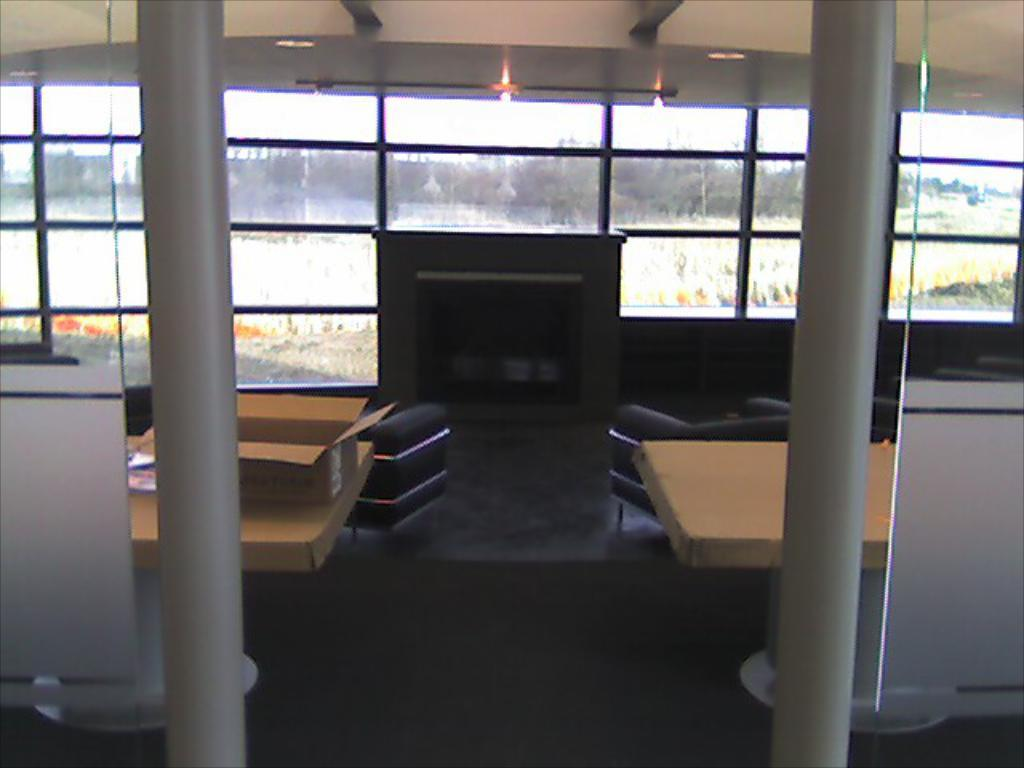What is the main piece of furniture in the image? There is a table in the image. What electronic device is on the table? There is a computer system on the table. What other objects are on the table? There is a box and a paper on the table. What can be seen in the background of the image? Water, trees, the sky, a pillar, and lights are visible in the background of the image. Can you tell me how many ears of yam are on the table in the image? There are no ears of yam present in the image; the table contains a computer system, a box, and a paper. 